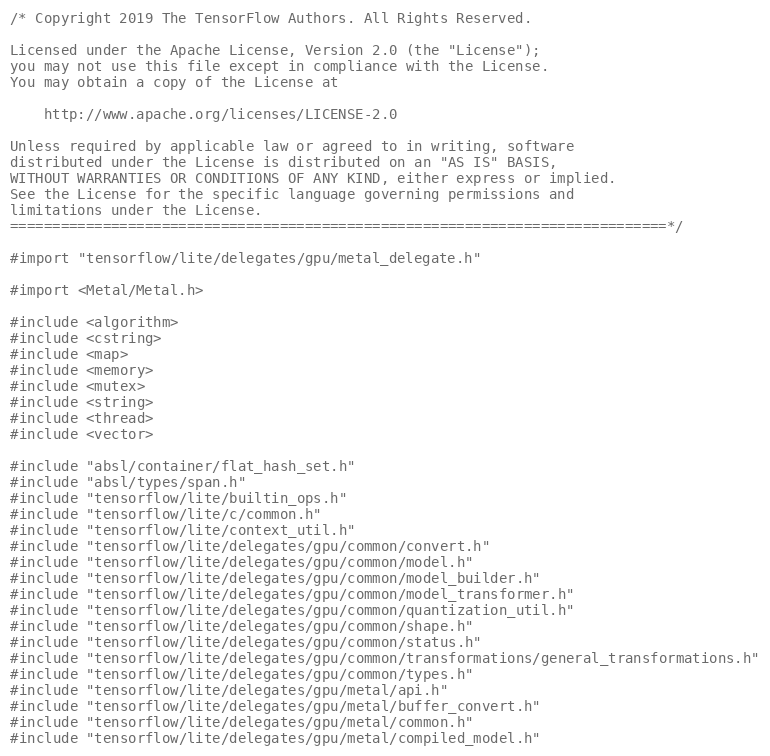<code> <loc_0><loc_0><loc_500><loc_500><_ObjectiveC_>/* Copyright 2019 The TensorFlow Authors. All Rights Reserved.

Licensed under the Apache License, Version 2.0 (the "License");
you may not use this file except in compliance with the License.
You may obtain a copy of the License at

    http://www.apache.org/licenses/LICENSE-2.0

Unless required by applicable law or agreed to in writing, software
distributed under the License is distributed on an "AS IS" BASIS,
WITHOUT WARRANTIES OR CONDITIONS OF ANY KIND, either express or implied.
See the License for the specific language governing permissions and
limitations under the License.
==============================================================================*/

#import "tensorflow/lite/delegates/gpu/metal_delegate.h"

#import <Metal/Metal.h>

#include <algorithm>
#include <cstring>
#include <map>
#include <memory>
#include <mutex>
#include <string>
#include <thread>
#include <vector>

#include "absl/container/flat_hash_set.h"
#include "absl/types/span.h"
#include "tensorflow/lite/builtin_ops.h"
#include "tensorflow/lite/c/common.h"
#include "tensorflow/lite/context_util.h"
#include "tensorflow/lite/delegates/gpu/common/convert.h"
#include "tensorflow/lite/delegates/gpu/common/model.h"
#include "tensorflow/lite/delegates/gpu/common/model_builder.h"
#include "tensorflow/lite/delegates/gpu/common/model_transformer.h"
#include "tensorflow/lite/delegates/gpu/common/quantization_util.h"
#include "tensorflow/lite/delegates/gpu/common/shape.h"
#include "tensorflow/lite/delegates/gpu/common/status.h"
#include "tensorflow/lite/delegates/gpu/common/transformations/general_transformations.h"
#include "tensorflow/lite/delegates/gpu/common/types.h"
#include "tensorflow/lite/delegates/gpu/metal/api.h"
#include "tensorflow/lite/delegates/gpu/metal/buffer_convert.h"
#include "tensorflow/lite/delegates/gpu/metal/common.h"
#include "tensorflow/lite/delegates/gpu/metal/compiled_model.h"</code> 